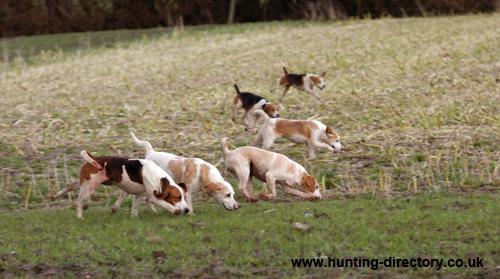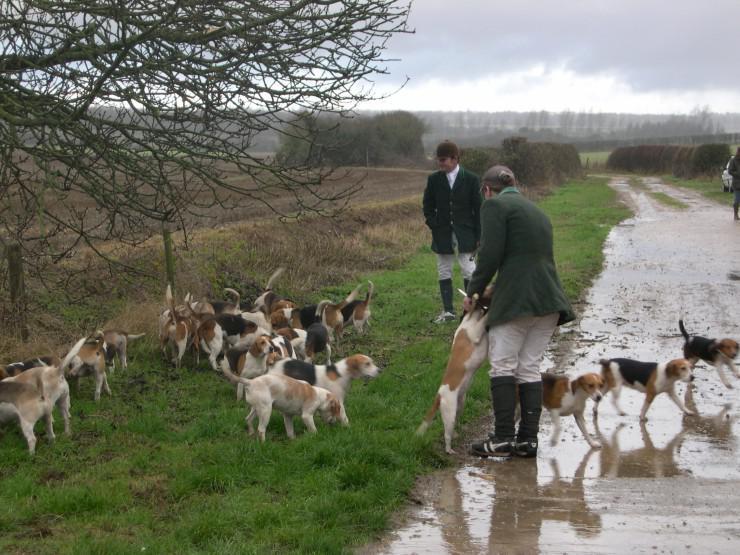The first image is the image on the left, the second image is the image on the right. Analyze the images presented: Is the assertion "An image shows a group of at least five people walking with a pack of dogs." valid? Answer yes or no. No. 